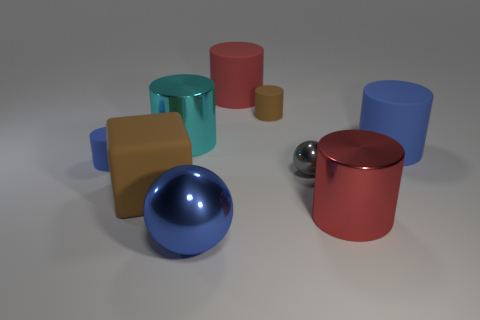Subtract all blue cylinders. How many cylinders are left? 4 Subtract all red cylinders. How many cylinders are left? 4 Subtract 1 blocks. How many blocks are left? 0 Add 1 tiny metallic blocks. How many objects exist? 10 Add 2 small rubber objects. How many small rubber objects exist? 4 Subtract 0 brown balls. How many objects are left? 9 Subtract all spheres. How many objects are left? 7 Subtract all red cylinders. Subtract all gray cubes. How many cylinders are left? 4 Subtract all red cubes. How many brown cylinders are left? 1 Subtract all matte cubes. Subtract all metal objects. How many objects are left? 4 